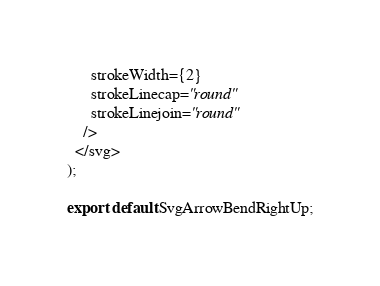<code> <loc_0><loc_0><loc_500><loc_500><_TypeScript_>      strokeWidth={2}
      strokeLinecap="round"
      strokeLinejoin="round"
    />
  </svg>
);

export default SvgArrowBendRightUp;
</code> 